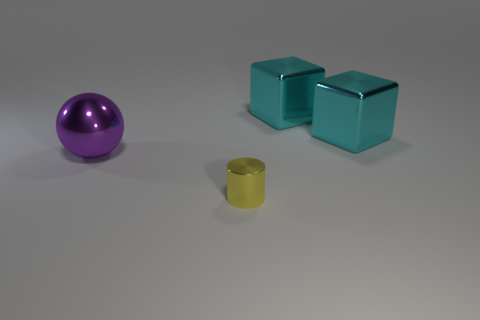How big is the thing in front of the metal thing on the left side of the metallic object that is in front of the sphere?
Give a very brief answer. Small. How many things are either big cyan metallic things or yellow cylinders?
Ensure brevity in your answer.  3. There is a small object; is its shape the same as the large metallic object on the left side of the small cylinder?
Offer a very short reply. No. There is a tiny yellow shiny object; are there any large purple shiny spheres behind it?
Your answer should be compact. Yes. What number of cubes are either large objects or tiny yellow rubber objects?
Offer a very short reply. 2. What size is the metallic thing that is to the left of the tiny yellow thing?
Offer a terse response. Large. There is a metallic thing that is on the left side of the yellow metallic cylinder; is it the same size as the metal cylinder?
Provide a short and direct response. No. The large metal ball is what color?
Ensure brevity in your answer.  Purple. There is a metallic thing that is on the left side of the shiny object in front of the large shiny ball; what is its color?
Your answer should be very brief. Purple. Are there any other big things made of the same material as the big purple object?
Give a very brief answer. Yes. 